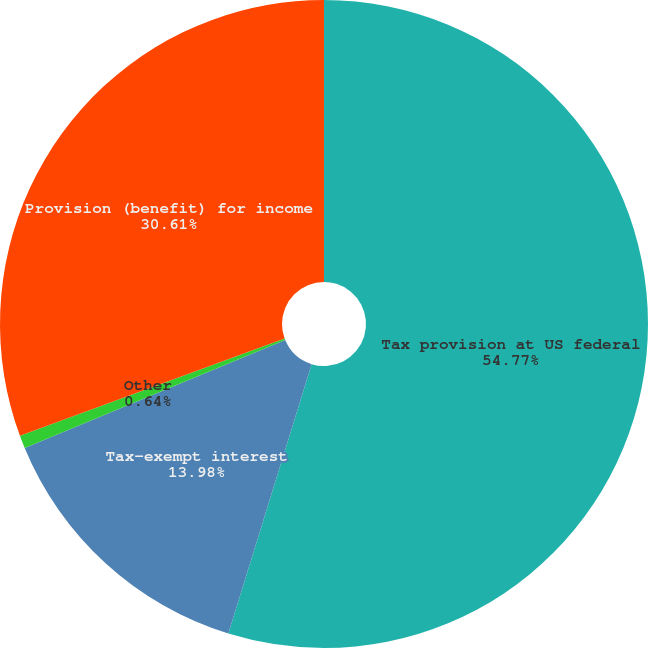<chart> <loc_0><loc_0><loc_500><loc_500><pie_chart><fcel>Tax provision at US federal<fcel>Tax-exempt interest<fcel>Other<fcel>Provision (benefit) for income<nl><fcel>54.77%<fcel>13.98%<fcel>0.64%<fcel>30.61%<nl></chart> 